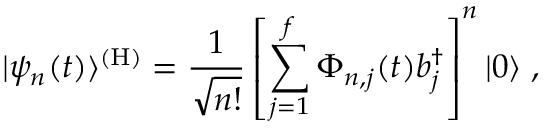<formula> <loc_0><loc_0><loc_500><loc_500>| \psi _ { n } ( t ) \rangle ^ { ( H ) } = { \frac { 1 } { \sqrt { n ! } } } \left [ \sum _ { j = 1 } ^ { f } \Phi _ { n , j } ( t ) b _ { j } ^ { \dagger } \right ] ^ { n } | 0 \rangle \, ,</formula> 